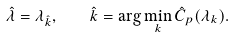<formula> <loc_0><loc_0><loc_500><loc_500>\hat { \lambda } = \lambda _ { \hat { k } } , \quad \hat { k } = \arg \min _ { k } \hat { C } _ { p } ( \lambda _ { k } ) .</formula> 